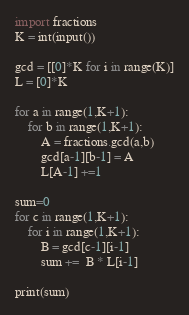Convert code to text. <code><loc_0><loc_0><loc_500><loc_500><_Python_>import fractions
K = int(input())

gcd = [[0]*K for i in range(K)]
L = [0]*K

for a in range(1,K+1):
    for b in range(1,K+1):
        A = fractions.gcd(a,b)
        gcd[a-1][b-1] = A
        L[A-1] +=1

sum=0
for c in range(1,K+1):
    for i in range(1,K+1):
        B = gcd[c-1][i-1]
        sum +=  B * L[i-1]

print(sum)</code> 